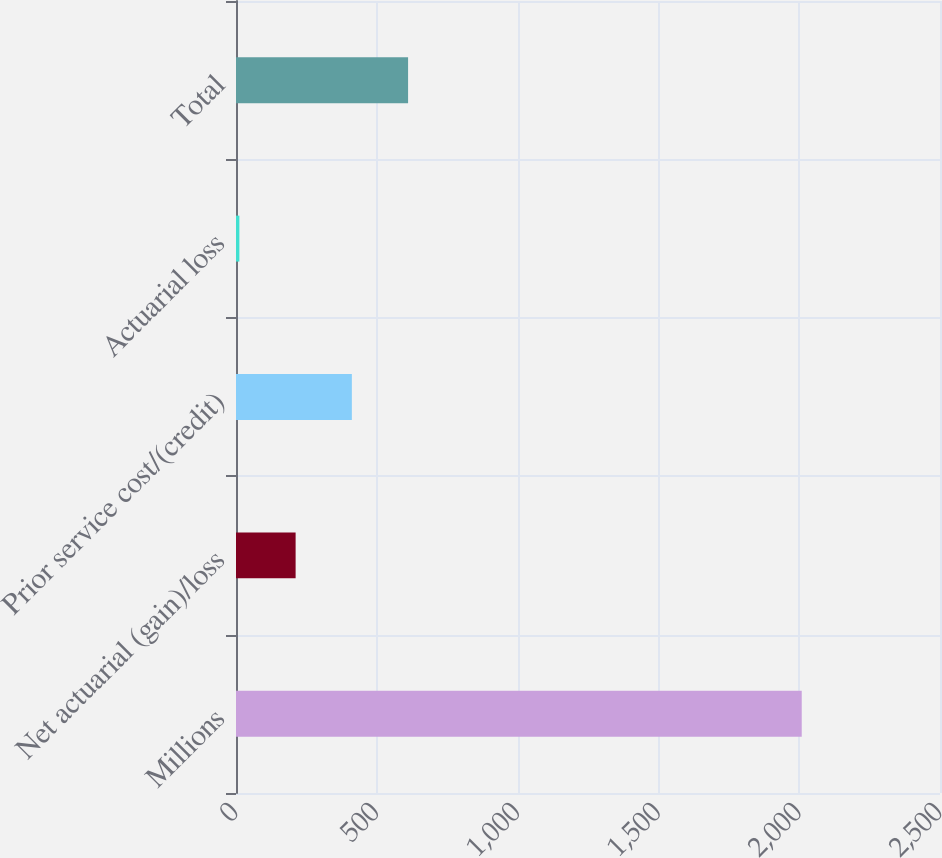<chart> <loc_0><loc_0><loc_500><loc_500><bar_chart><fcel>Millions<fcel>Net actuarial (gain)/loss<fcel>Prior service cost/(credit)<fcel>Actuarial loss<fcel>Total<nl><fcel>2009<fcel>211.7<fcel>411.4<fcel>12<fcel>611.1<nl></chart> 